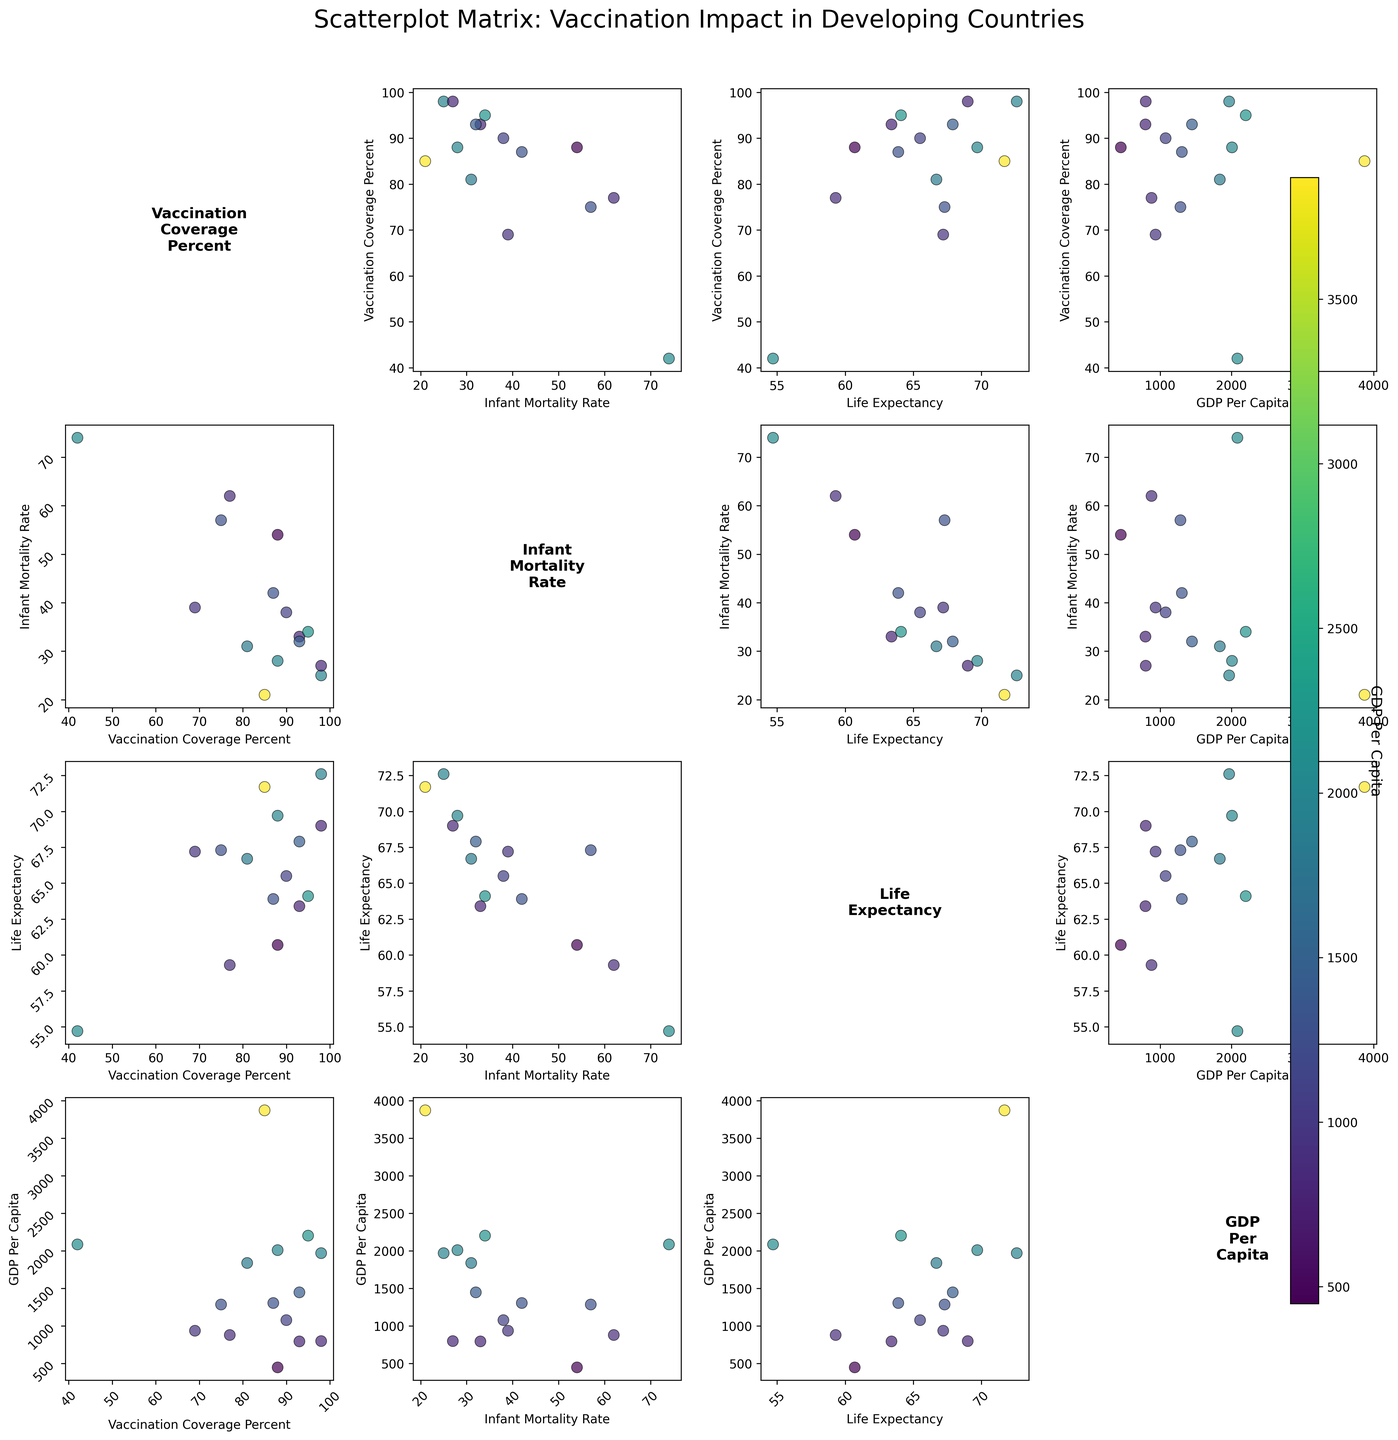What is the title of the plot? The title is usually placed at the top of the figure, and the title in this plot is located above the scatterplot matrix.
Answer: Scatterplot Matrix: Vaccination Impact in Developing Countries What is the relationship between Vaccination Coverage Percent and Infant Mortality Rate? To find the relationship, look at the scatterplot in the cell corresponding to "Vaccination Coverage Percent" on the y-axis and "Infant Mortality Rate" on the x-axis. Observe the pattern of points.
Answer: Generally, as vaccination coverage increases, the infant mortality rate tends to decrease Which country has the highest GDP Per Capita and where is it located in one of the scatter plots? Check the color scale on the right to determine GDP Per Capita and identify the country whose value corresponds to the highest color intensity. Then locate this country in one of the scatter plots, e.g., GDP Per Capita vs Life Expectancy.
Answer: Indonesia at approximately (3870, 71.7) Is there a country with 75% Vaccination Coverage and how is its GDP Per Capita compared to the average? Locate the data point with 75% vaccination coverage in the "Vaccination Coverage Percent" vs "GDP Per Capita" scatter plot and compare its GDP Per Capita against the average GDP Per Capita of all countries.
Answer: Yes, Pakistan has 75% vaccination coverage, and its GDP Per Capita (1285) is below the average GDP Per Capita What is the general trend observed between Life Expectancy and GDP Per Capita? Examine the scatter plot where Life Expectancy is on one axis and GDP Per Capita on the other. Identify if there is a rising or falling pattern.
Answer: As GDP Per Capita increases, Life Expectancy tends to increase Which country has one of the lowest Infant Mortality Rates and what is its Vaccination Coverage Percent? Identify the point on the "Vaccination Coverage Percent" vs "Infant Mortality Rate" scatter plot with the lowest Infant Mortality Rate and check its Vaccination Coverage Percent.
Answer: Indonesia, with 85% vaccination coverage, has one of the lowest Infant Mortality Rates (21) What can you infer about the relationship between GDP Per Capita and Infant Mortality Rate? Evaluate the scatter plot where GDP Per Capita is on one axis and Infant Mortality Rate on the other. Determine the presence or absence of a trend.
Answer: Generally, a higher GDP Per Capita is associated with a lower Infant Mortality Rate Compare the Infant Mortality Rates of countries with above 90% Vaccination Coverage. Focus on the countries with Vaccination Coverage above 90% and check their Infant Mortality Rates in the scatter plot. Compare these rates among the countries.
Answer: Uganda (33), Ghana (34), Senegal (32), and Tanzania (38) have varying rates, but all are comparatively lower Which scatter plot shows the strongest negative correlation? Inspect each scatter plot pair and identify which one shows the points most aligned in a downward trend.
Answer: The scatter plot of Infant Mortality Rate vs Vaccination Coverage Percent shows the strongest negative correlation What does the color of the data points in the scatter plots represent? Observe the color legend on the right side of the figure to determine what variable the colors correspond to.
Answer: GDP Per Capita 